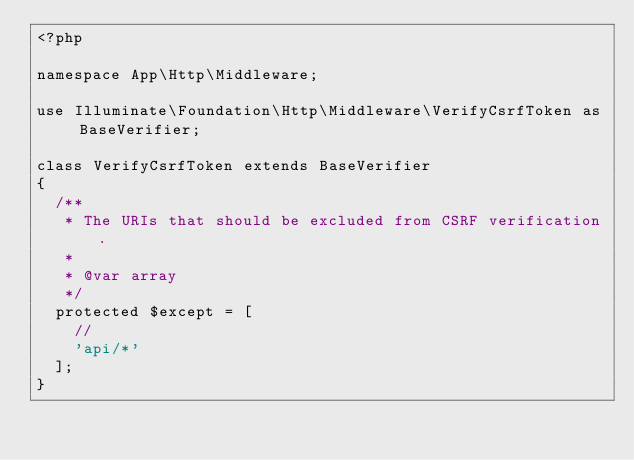Convert code to text. <code><loc_0><loc_0><loc_500><loc_500><_PHP_><?php

namespace App\Http\Middleware;

use Illuminate\Foundation\Http\Middleware\VerifyCsrfToken as BaseVerifier;

class VerifyCsrfToken extends BaseVerifier
{
	/**
	 * The URIs that should be excluded from CSRF verification.
	 *
	 * @var array
	 */
	protected $except = [
		//
		'api/*'
	];
}
</code> 